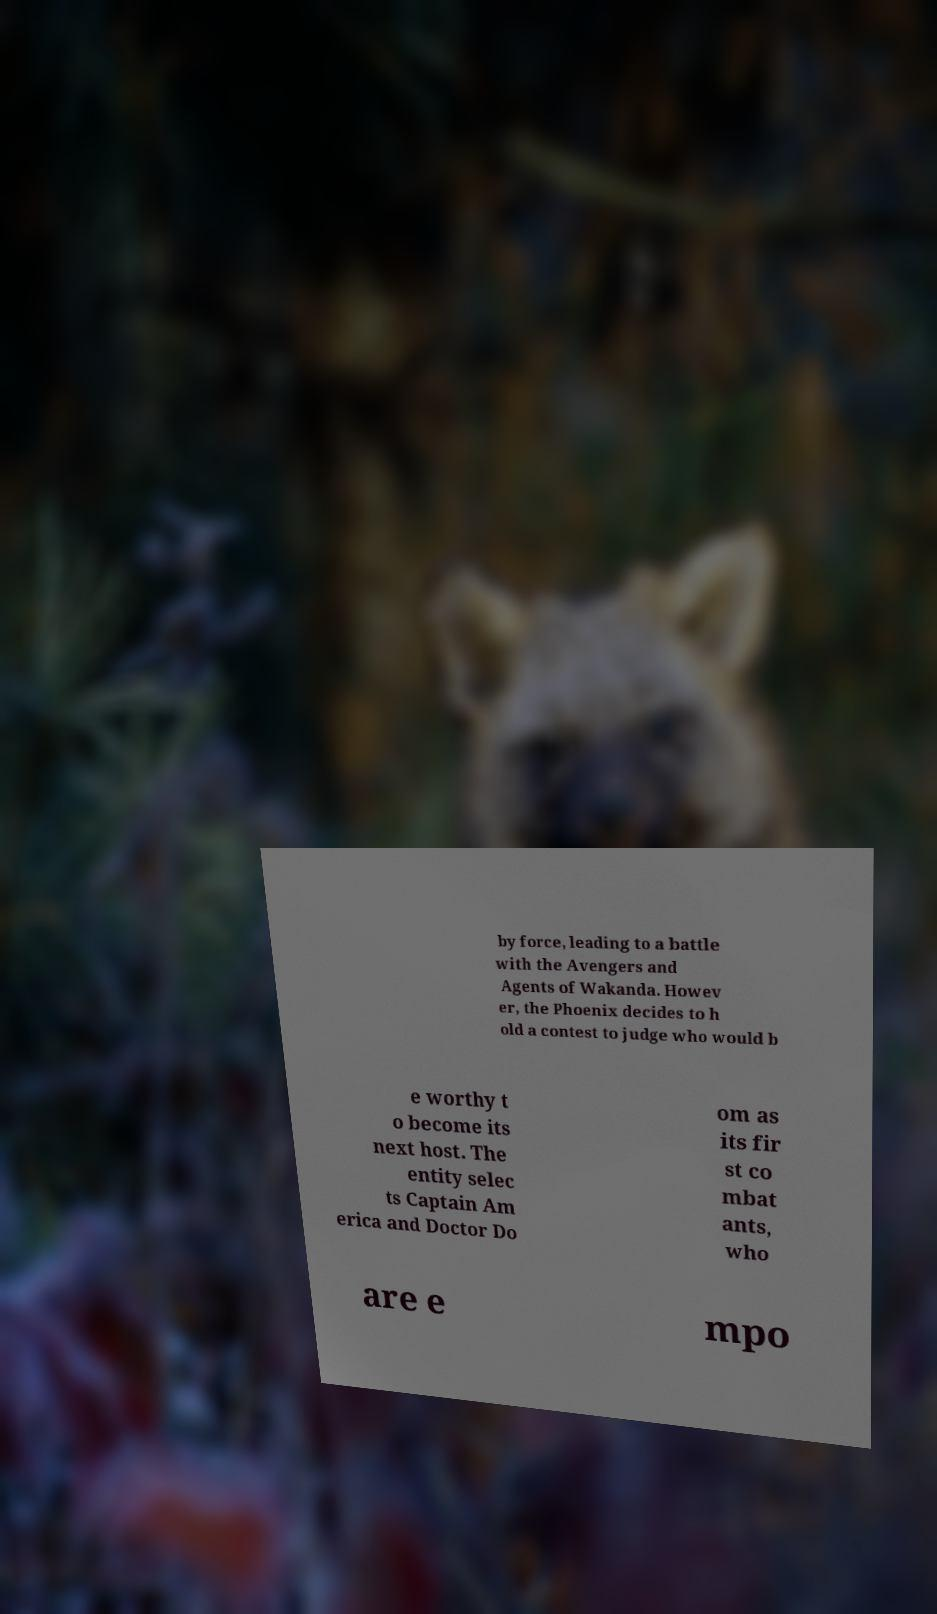There's text embedded in this image that I need extracted. Can you transcribe it verbatim? by force, leading to a battle with the Avengers and Agents of Wakanda. Howev er, the Phoenix decides to h old a contest to judge who would b e worthy t o become its next host. The entity selec ts Captain Am erica and Doctor Do om as its fir st co mbat ants, who are e mpo 